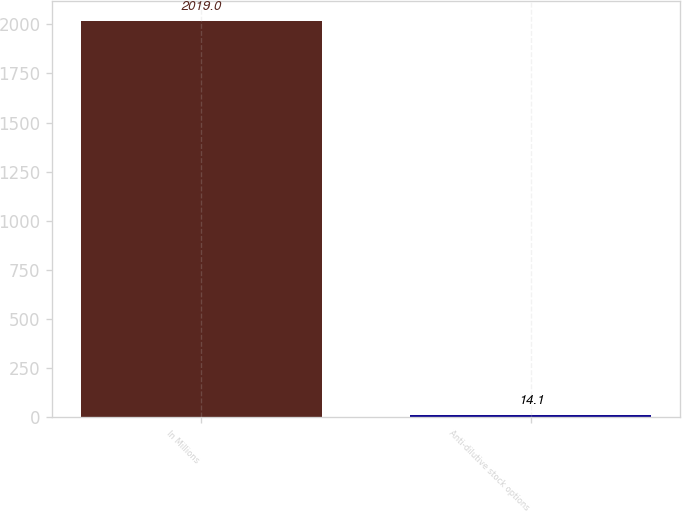Convert chart to OTSL. <chart><loc_0><loc_0><loc_500><loc_500><bar_chart><fcel>In Millions<fcel>Anti-dilutive stock options<nl><fcel>2019<fcel>14.1<nl></chart> 